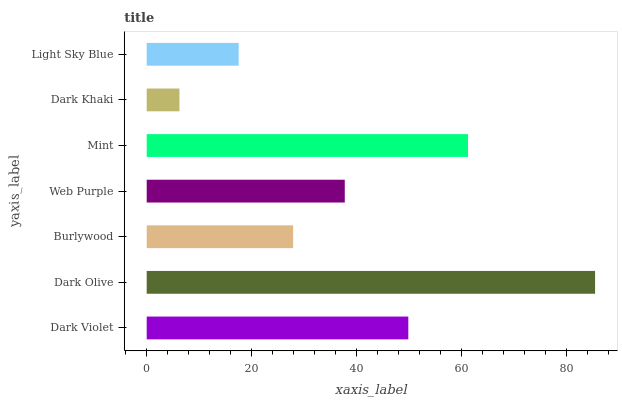Is Dark Khaki the minimum?
Answer yes or no. Yes. Is Dark Olive the maximum?
Answer yes or no. Yes. Is Burlywood the minimum?
Answer yes or no. No. Is Burlywood the maximum?
Answer yes or no. No. Is Dark Olive greater than Burlywood?
Answer yes or no. Yes. Is Burlywood less than Dark Olive?
Answer yes or no. Yes. Is Burlywood greater than Dark Olive?
Answer yes or no. No. Is Dark Olive less than Burlywood?
Answer yes or no. No. Is Web Purple the high median?
Answer yes or no. Yes. Is Web Purple the low median?
Answer yes or no. Yes. Is Dark Violet the high median?
Answer yes or no. No. Is Burlywood the low median?
Answer yes or no. No. 